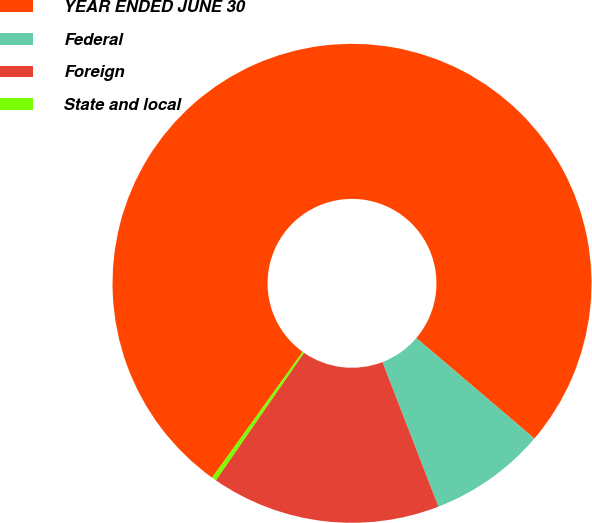Convert chart to OTSL. <chart><loc_0><loc_0><loc_500><loc_500><pie_chart><fcel>YEAR ENDED JUNE 30<fcel>Federal<fcel>Foreign<fcel>State and local<nl><fcel>76.29%<fcel>7.9%<fcel>15.5%<fcel>0.3%<nl></chart> 